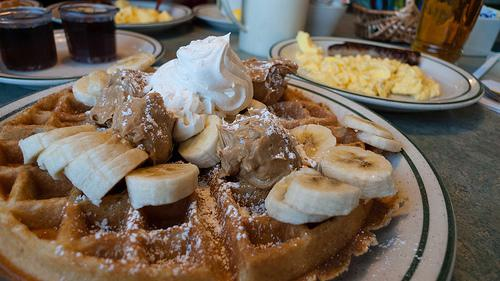Question: where are the plates?
Choices:
A. In the sink.
B. In the dishwasher.
C. On table.
D. On the ground.
Answer with the letter. Answer: C Question: what is yellow?
Choices:
A. Flower.
B. Shirt.
C. Crayon.
D. Eggs.
Answer with the letter. Answer: D Question: what has bananas, cream and chocolate mousse on it?
Choices:
A. Pancake.
B. Ice cream.
C. Sandwich.
D. Waffle.
Answer with the letter. Answer: D Question: why is there a cup?
Choices:
A. Soda.
B. Beer.
C. Coffee.
D. Water.
Answer with the letter. Answer: C Question: what is on the plate with bananas?
Choices:
A. Fork.
B. Breakfast.
C. Spoon.
D. Napkin.
Answer with the letter. Answer: B Question: who would eat this food?
Choices:
A. People.
B. No one.
C. Dogs.
D. Cats.
Answer with the letter. Answer: A 